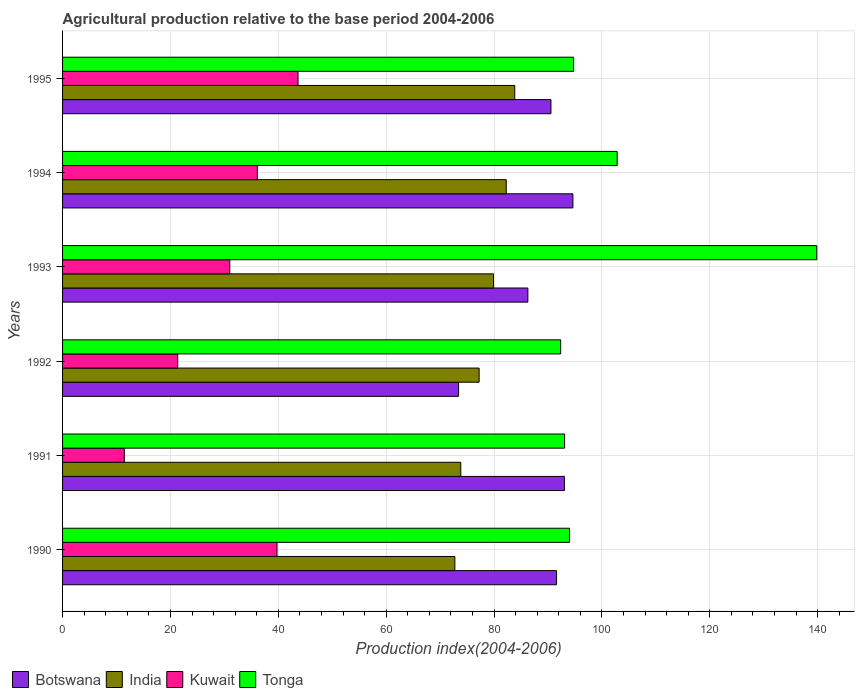How many bars are there on the 1st tick from the top?
Keep it short and to the point. 4. How many bars are there on the 5th tick from the bottom?
Offer a very short reply. 4. In how many cases, is the number of bars for a given year not equal to the number of legend labels?
Give a very brief answer. 0. What is the agricultural production index in Kuwait in 1992?
Give a very brief answer. 21.35. Across all years, what is the maximum agricultural production index in Botswana?
Provide a succinct answer. 94.63. Across all years, what is the minimum agricultural production index in Botswana?
Ensure brevity in your answer.  73.43. In which year was the agricultural production index in India minimum?
Your response must be concise. 1990. What is the total agricultural production index in Tonga in the graph?
Provide a short and direct response. 616.89. What is the difference between the agricultural production index in Kuwait in 1991 and that in 1992?
Give a very brief answer. -9.9. What is the difference between the agricultural production index in India in 1990 and the agricultural production index in Kuwait in 1992?
Provide a short and direct response. 51.39. What is the average agricultural production index in Kuwait per year?
Keep it short and to the point. 30.56. In the year 1994, what is the difference between the agricultural production index in India and agricultural production index in Botswana?
Your answer should be compact. -12.36. In how many years, is the agricultural production index in Tonga greater than 44 ?
Ensure brevity in your answer.  6. What is the ratio of the agricultural production index in Botswana in 1991 to that in 1992?
Keep it short and to the point. 1.27. What is the difference between the highest and the second highest agricultural production index in Botswana?
Give a very brief answer. 1.58. What is the difference between the highest and the lowest agricultural production index in Tonga?
Provide a short and direct response. 47.49. Is the sum of the agricultural production index in Kuwait in 1991 and 1992 greater than the maximum agricultural production index in India across all years?
Give a very brief answer. No. Is it the case that in every year, the sum of the agricultural production index in Kuwait and agricultural production index in Tonga is greater than the sum of agricultural production index in Botswana and agricultural production index in India?
Your answer should be very brief. No. What does the 1st bar from the top in 1995 represents?
Give a very brief answer. Tonga. Are all the bars in the graph horizontal?
Your response must be concise. Yes. How many years are there in the graph?
Your answer should be compact. 6. What is the difference between two consecutive major ticks on the X-axis?
Offer a terse response. 20. Are the values on the major ticks of X-axis written in scientific E-notation?
Your answer should be very brief. No. Does the graph contain any zero values?
Your response must be concise. No. Does the graph contain grids?
Make the answer very short. Yes. How many legend labels are there?
Give a very brief answer. 4. What is the title of the graph?
Offer a terse response. Agricultural production relative to the base period 2004-2006. What is the label or title of the X-axis?
Offer a very short reply. Production index(2004-2006). What is the Production index(2004-2006) in Botswana in 1990?
Offer a terse response. 91.6. What is the Production index(2004-2006) of India in 1990?
Your answer should be compact. 72.74. What is the Production index(2004-2006) of Kuwait in 1990?
Ensure brevity in your answer.  39.76. What is the Production index(2004-2006) in Tonga in 1990?
Your answer should be compact. 94. What is the Production index(2004-2006) of Botswana in 1991?
Keep it short and to the point. 93.05. What is the Production index(2004-2006) in India in 1991?
Provide a succinct answer. 73.84. What is the Production index(2004-2006) of Kuwait in 1991?
Keep it short and to the point. 11.45. What is the Production index(2004-2006) in Tonga in 1991?
Offer a terse response. 93.09. What is the Production index(2004-2006) in Botswana in 1992?
Provide a short and direct response. 73.43. What is the Production index(2004-2006) of India in 1992?
Offer a very short reply. 77.24. What is the Production index(2004-2006) in Kuwait in 1992?
Offer a terse response. 21.35. What is the Production index(2004-2006) of Tonga in 1992?
Your answer should be compact. 92.36. What is the Production index(2004-2006) of Botswana in 1993?
Ensure brevity in your answer.  86.28. What is the Production index(2004-2006) in India in 1993?
Provide a succinct answer. 79.91. What is the Production index(2004-2006) of Kuwait in 1993?
Offer a terse response. 31.01. What is the Production index(2004-2006) of Tonga in 1993?
Your answer should be compact. 139.85. What is the Production index(2004-2006) of Botswana in 1994?
Keep it short and to the point. 94.63. What is the Production index(2004-2006) in India in 1994?
Ensure brevity in your answer.  82.27. What is the Production index(2004-2006) of Kuwait in 1994?
Your answer should be compact. 36.12. What is the Production index(2004-2006) of Tonga in 1994?
Offer a terse response. 102.84. What is the Production index(2004-2006) in Botswana in 1995?
Make the answer very short. 90.56. What is the Production index(2004-2006) of India in 1995?
Make the answer very short. 83.85. What is the Production index(2004-2006) in Kuwait in 1995?
Give a very brief answer. 43.66. What is the Production index(2004-2006) in Tonga in 1995?
Your answer should be compact. 94.75. Across all years, what is the maximum Production index(2004-2006) of Botswana?
Your response must be concise. 94.63. Across all years, what is the maximum Production index(2004-2006) of India?
Provide a short and direct response. 83.85. Across all years, what is the maximum Production index(2004-2006) in Kuwait?
Your answer should be very brief. 43.66. Across all years, what is the maximum Production index(2004-2006) in Tonga?
Offer a terse response. 139.85. Across all years, what is the minimum Production index(2004-2006) of Botswana?
Make the answer very short. 73.43. Across all years, what is the minimum Production index(2004-2006) of India?
Your answer should be very brief. 72.74. Across all years, what is the minimum Production index(2004-2006) of Kuwait?
Make the answer very short. 11.45. Across all years, what is the minimum Production index(2004-2006) in Tonga?
Your answer should be very brief. 92.36. What is the total Production index(2004-2006) of Botswana in the graph?
Offer a terse response. 529.55. What is the total Production index(2004-2006) of India in the graph?
Keep it short and to the point. 469.85. What is the total Production index(2004-2006) in Kuwait in the graph?
Offer a very short reply. 183.35. What is the total Production index(2004-2006) of Tonga in the graph?
Your answer should be compact. 616.89. What is the difference between the Production index(2004-2006) of Botswana in 1990 and that in 1991?
Keep it short and to the point. -1.45. What is the difference between the Production index(2004-2006) of India in 1990 and that in 1991?
Your answer should be compact. -1.1. What is the difference between the Production index(2004-2006) in Kuwait in 1990 and that in 1991?
Keep it short and to the point. 28.31. What is the difference between the Production index(2004-2006) of Tonga in 1990 and that in 1991?
Give a very brief answer. 0.91. What is the difference between the Production index(2004-2006) in Botswana in 1990 and that in 1992?
Provide a succinct answer. 18.17. What is the difference between the Production index(2004-2006) in Kuwait in 1990 and that in 1992?
Your answer should be very brief. 18.41. What is the difference between the Production index(2004-2006) in Tonga in 1990 and that in 1992?
Ensure brevity in your answer.  1.64. What is the difference between the Production index(2004-2006) in Botswana in 1990 and that in 1993?
Offer a very short reply. 5.32. What is the difference between the Production index(2004-2006) in India in 1990 and that in 1993?
Ensure brevity in your answer.  -7.17. What is the difference between the Production index(2004-2006) in Kuwait in 1990 and that in 1993?
Make the answer very short. 8.75. What is the difference between the Production index(2004-2006) of Tonga in 1990 and that in 1993?
Make the answer very short. -45.85. What is the difference between the Production index(2004-2006) of Botswana in 1990 and that in 1994?
Keep it short and to the point. -3.03. What is the difference between the Production index(2004-2006) of India in 1990 and that in 1994?
Your response must be concise. -9.53. What is the difference between the Production index(2004-2006) in Kuwait in 1990 and that in 1994?
Provide a succinct answer. 3.64. What is the difference between the Production index(2004-2006) in Tonga in 1990 and that in 1994?
Your response must be concise. -8.84. What is the difference between the Production index(2004-2006) of Botswana in 1990 and that in 1995?
Your response must be concise. 1.04. What is the difference between the Production index(2004-2006) in India in 1990 and that in 1995?
Provide a short and direct response. -11.11. What is the difference between the Production index(2004-2006) of Tonga in 1990 and that in 1995?
Ensure brevity in your answer.  -0.75. What is the difference between the Production index(2004-2006) in Botswana in 1991 and that in 1992?
Provide a succinct answer. 19.62. What is the difference between the Production index(2004-2006) of Tonga in 1991 and that in 1992?
Offer a terse response. 0.73. What is the difference between the Production index(2004-2006) of Botswana in 1991 and that in 1993?
Provide a short and direct response. 6.77. What is the difference between the Production index(2004-2006) in India in 1991 and that in 1993?
Your answer should be compact. -6.07. What is the difference between the Production index(2004-2006) of Kuwait in 1991 and that in 1993?
Provide a short and direct response. -19.56. What is the difference between the Production index(2004-2006) in Tonga in 1991 and that in 1993?
Keep it short and to the point. -46.76. What is the difference between the Production index(2004-2006) of Botswana in 1991 and that in 1994?
Your response must be concise. -1.58. What is the difference between the Production index(2004-2006) in India in 1991 and that in 1994?
Your response must be concise. -8.43. What is the difference between the Production index(2004-2006) in Kuwait in 1991 and that in 1994?
Offer a very short reply. -24.67. What is the difference between the Production index(2004-2006) of Tonga in 1991 and that in 1994?
Your answer should be very brief. -9.75. What is the difference between the Production index(2004-2006) in Botswana in 1991 and that in 1995?
Your answer should be very brief. 2.49. What is the difference between the Production index(2004-2006) in India in 1991 and that in 1995?
Your response must be concise. -10.01. What is the difference between the Production index(2004-2006) of Kuwait in 1991 and that in 1995?
Offer a terse response. -32.21. What is the difference between the Production index(2004-2006) of Tonga in 1991 and that in 1995?
Keep it short and to the point. -1.66. What is the difference between the Production index(2004-2006) in Botswana in 1992 and that in 1993?
Offer a terse response. -12.85. What is the difference between the Production index(2004-2006) in India in 1992 and that in 1993?
Make the answer very short. -2.67. What is the difference between the Production index(2004-2006) of Kuwait in 1992 and that in 1993?
Keep it short and to the point. -9.66. What is the difference between the Production index(2004-2006) of Tonga in 1992 and that in 1993?
Provide a succinct answer. -47.49. What is the difference between the Production index(2004-2006) in Botswana in 1992 and that in 1994?
Your answer should be compact. -21.2. What is the difference between the Production index(2004-2006) of India in 1992 and that in 1994?
Your response must be concise. -5.03. What is the difference between the Production index(2004-2006) in Kuwait in 1992 and that in 1994?
Offer a very short reply. -14.77. What is the difference between the Production index(2004-2006) in Tonga in 1992 and that in 1994?
Offer a terse response. -10.48. What is the difference between the Production index(2004-2006) of Botswana in 1992 and that in 1995?
Your answer should be very brief. -17.13. What is the difference between the Production index(2004-2006) in India in 1992 and that in 1995?
Give a very brief answer. -6.61. What is the difference between the Production index(2004-2006) in Kuwait in 1992 and that in 1995?
Provide a short and direct response. -22.31. What is the difference between the Production index(2004-2006) in Tonga in 1992 and that in 1995?
Your answer should be very brief. -2.39. What is the difference between the Production index(2004-2006) of Botswana in 1993 and that in 1994?
Your answer should be compact. -8.35. What is the difference between the Production index(2004-2006) in India in 1993 and that in 1994?
Your answer should be compact. -2.36. What is the difference between the Production index(2004-2006) in Kuwait in 1993 and that in 1994?
Provide a short and direct response. -5.11. What is the difference between the Production index(2004-2006) of Tonga in 1993 and that in 1994?
Provide a succinct answer. 37.01. What is the difference between the Production index(2004-2006) in Botswana in 1993 and that in 1995?
Offer a terse response. -4.28. What is the difference between the Production index(2004-2006) in India in 1993 and that in 1995?
Keep it short and to the point. -3.94. What is the difference between the Production index(2004-2006) in Kuwait in 1993 and that in 1995?
Your answer should be compact. -12.65. What is the difference between the Production index(2004-2006) of Tonga in 1993 and that in 1995?
Give a very brief answer. 45.1. What is the difference between the Production index(2004-2006) in Botswana in 1994 and that in 1995?
Keep it short and to the point. 4.07. What is the difference between the Production index(2004-2006) of India in 1994 and that in 1995?
Offer a terse response. -1.58. What is the difference between the Production index(2004-2006) in Kuwait in 1994 and that in 1995?
Offer a terse response. -7.54. What is the difference between the Production index(2004-2006) of Tonga in 1994 and that in 1995?
Make the answer very short. 8.09. What is the difference between the Production index(2004-2006) of Botswana in 1990 and the Production index(2004-2006) of India in 1991?
Your answer should be very brief. 17.76. What is the difference between the Production index(2004-2006) of Botswana in 1990 and the Production index(2004-2006) of Kuwait in 1991?
Make the answer very short. 80.15. What is the difference between the Production index(2004-2006) in Botswana in 1990 and the Production index(2004-2006) in Tonga in 1991?
Your answer should be very brief. -1.49. What is the difference between the Production index(2004-2006) of India in 1990 and the Production index(2004-2006) of Kuwait in 1991?
Provide a succinct answer. 61.29. What is the difference between the Production index(2004-2006) in India in 1990 and the Production index(2004-2006) in Tonga in 1991?
Make the answer very short. -20.35. What is the difference between the Production index(2004-2006) in Kuwait in 1990 and the Production index(2004-2006) in Tonga in 1991?
Make the answer very short. -53.33. What is the difference between the Production index(2004-2006) of Botswana in 1990 and the Production index(2004-2006) of India in 1992?
Your answer should be compact. 14.36. What is the difference between the Production index(2004-2006) in Botswana in 1990 and the Production index(2004-2006) in Kuwait in 1992?
Offer a very short reply. 70.25. What is the difference between the Production index(2004-2006) in Botswana in 1990 and the Production index(2004-2006) in Tonga in 1992?
Your answer should be compact. -0.76. What is the difference between the Production index(2004-2006) in India in 1990 and the Production index(2004-2006) in Kuwait in 1992?
Provide a short and direct response. 51.39. What is the difference between the Production index(2004-2006) of India in 1990 and the Production index(2004-2006) of Tonga in 1992?
Provide a succinct answer. -19.62. What is the difference between the Production index(2004-2006) in Kuwait in 1990 and the Production index(2004-2006) in Tonga in 1992?
Ensure brevity in your answer.  -52.6. What is the difference between the Production index(2004-2006) in Botswana in 1990 and the Production index(2004-2006) in India in 1993?
Offer a terse response. 11.69. What is the difference between the Production index(2004-2006) of Botswana in 1990 and the Production index(2004-2006) of Kuwait in 1993?
Provide a succinct answer. 60.59. What is the difference between the Production index(2004-2006) of Botswana in 1990 and the Production index(2004-2006) of Tonga in 1993?
Provide a succinct answer. -48.25. What is the difference between the Production index(2004-2006) of India in 1990 and the Production index(2004-2006) of Kuwait in 1993?
Offer a very short reply. 41.73. What is the difference between the Production index(2004-2006) in India in 1990 and the Production index(2004-2006) in Tonga in 1993?
Your answer should be compact. -67.11. What is the difference between the Production index(2004-2006) of Kuwait in 1990 and the Production index(2004-2006) of Tonga in 1993?
Offer a terse response. -100.09. What is the difference between the Production index(2004-2006) of Botswana in 1990 and the Production index(2004-2006) of India in 1994?
Give a very brief answer. 9.33. What is the difference between the Production index(2004-2006) of Botswana in 1990 and the Production index(2004-2006) of Kuwait in 1994?
Ensure brevity in your answer.  55.48. What is the difference between the Production index(2004-2006) in Botswana in 1990 and the Production index(2004-2006) in Tonga in 1994?
Ensure brevity in your answer.  -11.24. What is the difference between the Production index(2004-2006) in India in 1990 and the Production index(2004-2006) in Kuwait in 1994?
Ensure brevity in your answer.  36.62. What is the difference between the Production index(2004-2006) in India in 1990 and the Production index(2004-2006) in Tonga in 1994?
Offer a terse response. -30.1. What is the difference between the Production index(2004-2006) of Kuwait in 1990 and the Production index(2004-2006) of Tonga in 1994?
Make the answer very short. -63.08. What is the difference between the Production index(2004-2006) in Botswana in 1990 and the Production index(2004-2006) in India in 1995?
Make the answer very short. 7.75. What is the difference between the Production index(2004-2006) of Botswana in 1990 and the Production index(2004-2006) of Kuwait in 1995?
Keep it short and to the point. 47.94. What is the difference between the Production index(2004-2006) of Botswana in 1990 and the Production index(2004-2006) of Tonga in 1995?
Offer a terse response. -3.15. What is the difference between the Production index(2004-2006) of India in 1990 and the Production index(2004-2006) of Kuwait in 1995?
Keep it short and to the point. 29.08. What is the difference between the Production index(2004-2006) in India in 1990 and the Production index(2004-2006) in Tonga in 1995?
Your answer should be very brief. -22.01. What is the difference between the Production index(2004-2006) of Kuwait in 1990 and the Production index(2004-2006) of Tonga in 1995?
Keep it short and to the point. -54.99. What is the difference between the Production index(2004-2006) of Botswana in 1991 and the Production index(2004-2006) of India in 1992?
Give a very brief answer. 15.81. What is the difference between the Production index(2004-2006) of Botswana in 1991 and the Production index(2004-2006) of Kuwait in 1992?
Provide a short and direct response. 71.7. What is the difference between the Production index(2004-2006) in Botswana in 1991 and the Production index(2004-2006) in Tonga in 1992?
Provide a succinct answer. 0.69. What is the difference between the Production index(2004-2006) of India in 1991 and the Production index(2004-2006) of Kuwait in 1992?
Ensure brevity in your answer.  52.49. What is the difference between the Production index(2004-2006) in India in 1991 and the Production index(2004-2006) in Tonga in 1992?
Provide a short and direct response. -18.52. What is the difference between the Production index(2004-2006) of Kuwait in 1991 and the Production index(2004-2006) of Tonga in 1992?
Ensure brevity in your answer.  -80.91. What is the difference between the Production index(2004-2006) in Botswana in 1991 and the Production index(2004-2006) in India in 1993?
Provide a short and direct response. 13.14. What is the difference between the Production index(2004-2006) in Botswana in 1991 and the Production index(2004-2006) in Kuwait in 1993?
Your answer should be compact. 62.04. What is the difference between the Production index(2004-2006) of Botswana in 1991 and the Production index(2004-2006) of Tonga in 1993?
Your response must be concise. -46.8. What is the difference between the Production index(2004-2006) in India in 1991 and the Production index(2004-2006) in Kuwait in 1993?
Your answer should be very brief. 42.83. What is the difference between the Production index(2004-2006) in India in 1991 and the Production index(2004-2006) in Tonga in 1993?
Offer a very short reply. -66.01. What is the difference between the Production index(2004-2006) in Kuwait in 1991 and the Production index(2004-2006) in Tonga in 1993?
Make the answer very short. -128.4. What is the difference between the Production index(2004-2006) of Botswana in 1991 and the Production index(2004-2006) of India in 1994?
Your answer should be very brief. 10.78. What is the difference between the Production index(2004-2006) of Botswana in 1991 and the Production index(2004-2006) of Kuwait in 1994?
Your answer should be very brief. 56.93. What is the difference between the Production index(2004-2006) in Botswana in 1991 and the Production index(2004-2006) in Tonga in 1994?
Your response must be concise. -9.79. What is the difference between the Production index(2004-2006) of India in 1991 and the Production index(2004-2006) of Kuwait in 1994?
Your answer should be compact. 37.72. What is the difference between the Production index(2004-2006) of Kuwait in 1991 and the Production index(2004-2006) of Tonga in 1994?
Offer a terse response. -91.39. What is the difference between the Production index(2004-2006) in Botswana in 1991 and the Production index(2004-2006) in India in 1995?
Offer a very short reply. 9.2. What is the difference between the Production index(2004-2006) in Botswana in 1991 and the Production index(2004-2006) in Kuwait in 1995?
Your answer should be very brief. 49.39. What is the difference between the Production index(2004-2006) of Botswana in 1991 and the Production index(2004-2006) of Tonga in 1995?
Make the answer very short. -1.7. What is the difference between the Production index(2004-2006) of India in 1991 and the Production index(2004-2006) of Kuwait in 1995?
Keep it short and to the point. 30.18. What is the difference between the Production index(2004-2006) of India in 1991 and the Production index(2004-2006) of Tonga in 1995?
Offer a terse response. -20.91. What is the difference between the Production index(2004-2006) in Kuwait in 1991 and the Production index(2004-2006) in Tonga in 1995?
Your answer should be very brief. -83.3. What is the difference between the Production index(2004-2006) in Botswana in 1992 and the Production index(2004-2006) in India in 1993?
Offer a very short reply. -6.48. What is the difference between the Production index(2004-2006) in Botswana in 1992 and the Production index(2004-2006) in Kuwait in 1993?
Make the answer very short. 42.42. What is the difference between the Production index(2004-2006) of Botswana in 1992 and the Production index(2004-2006) of Tonga in 1993?
Provide a short and direct response. -66.42. What is the difference between the Production index(2004-2006) in India in 1992 and the Production index(2004-2006) in Kuwait in 1993?
Provide a short and direct response. 46.23. What is the difference between the Production index(2004-2006) in India in 1992 and the Production index(2004-2006) in Tonga in 1993?
Provide a short and direct response. -62.61. What is the difference between the Production index(2004-2006) of Kuwait in 1992 and the Production index(2004-2006) of Tonga in 1993?
Your answer should be very brief. -118.5. What is the difference between the Production index(2004-2006) in Botswana in 1992 and the Production index(2004-2006) in India in 1994?
Your response must be concise. -8.84. What is the difference between the Production index(2004-2006) in Botswana in 1992 and the Production index(2004-2006) in Kuwait in 1994?
Keep it short and to the point. 37.31. What is the difference between the Production index(2004-2006) in Botswana in 1992 and the Production index(2004-2006) in Tonga in 1994?
Provide a succinct answer. -29.41. What is the difference between the Production index(2004-2006) in India in 1992 and the Production index(2004-2006) in Kuwait in 1994?
Make the answer very short. 41.12. What is the difference between the Production index(2004-2006) of India in 1992 and the Production index(2004-2006) of Tonga in 1994?
Your response must be concise. -25.6. What is the difference between the Production index(2004-2006) in Kuwait in 1992 and the Production index(2004-2006) in Tonga in 1994?
Your answer should be very brief. -81.49. What is the difference between the Production index(2004-2006) in Botswana in 1992 and the Production index(2004-2006) in India in 1995?
Provide a short and direct response. -10.42. What is the difference between the Production index(2004-2006) in Botswana in 1992 and the Production index(2004-2006) in Kuwait in 1995?
Provide a short and direct response. 29.77. What is the difference between the Production index(2004-2006) in Botswana in 1992 and the Production index(2004-2006) in Tonga in 1995?
Provide a short and direct response. -21.32. What is the difference between the Production index(2004-2006) in India in 1992 and the Production index(2004-2006) in Kuwait in 1995?
Keep it short and to the point. 33.58. What is the difference between the Production index(2004-2006) of India in 1992 and the Production index(2004-2006) of Tonga in 1995?
Your answer should be very brief. -17.51. What is the difference between the Production index(2004-2006) in Kuwait in 1992 and the Production index(2004-2006) in Tonga in 1995?
Offer a very short reply. -73.4. What is the difference between the Production index(2004-2006) of Botswana in 1993 and the Production index(2004-2006) of India in 1994?
Your response must be concise. 4.01. What is the difference between the Production index(2004-2006) in Botswana in 1993 and the Production index(2004-2006) in Kuwait in 1994?
Your answer should be very brief. 50.16. What is the difference between the Production index(2004-2006) in Botswana in 1993 and the Production index(2004-2006) in Tonga in 1994?
Make the answer very short. -16.56. What is the difference between the Production index(2004-2006) of India in 1993 and the Production index(2004-2006) of Kuwait in 1994?
Keep it short and to the point. 43.79. What is the difference between the Production index(2004-2006) of India in 1993 and the Production index(2004-2006) of Tonga in 1994?
Your answer should be compact. -22.93. What is the difference between the Production index(2004-2006) in Kuwait in 1993 and the Production index(2004-2006) in Tonga in 1994?
Provide a short and direct response. -71.83. What is the difference between the Production index(2004-2006) in Botswana in 1993 and the Production index(2004-2006) in India in 1995?
Your answer should be compact. 2.43. What is the difference between the Production index(2004-2006) in Botswana in 1993 and the Production index(2004-2006) in Kuwait in 1995?
Offer a very short reply. 42.62. What is the difference between the Production index(2004-2006) in Botswana in 1993 and the Production index(2004-2006) in Tonga in 1995?
Offer a terse response. -8.47. What is the difference between the Production index(2004-2006) of India in 1993 and the Production index(2004-2006) of Kuwait in 1995?
Give a very brief answer. 36.25. What is the difference between the Production index(2004-2006) of India in 1993 and the Production index(2004-2006) of Tonga in 1995?
Your answer should be very brief. -14.84. What is the difference between the Production index(2004-2006) in Kuwait in 1993 and the Production index(2004-2006) in Tonga in 1995?
Make the answer very short. -63.74. What is the difference between the Production index(2004-2006) in Botswana in 1994 and the Production index(2004-2006) in India in 1995?
Keep it short and to the point. 10.78. What is the difference between the Production index(2004-2006) of Botswana in 1994 and the Production index(2004-2006) of Kuwait in 1995?
Give a very brief answer. 50.97. What is the difference between the Production index(2004-2006) in Botswana in 1994 and the Production index(2004-2006) in Tonga in 1995?
Offer a very short reply. -0.12. What is the difference between the Production index(2004-2006) in India in 1994 and the Production index(2004-2006) in Kuwait in 1995?
Provide a succinct answer. 38.61. What is the difference between the Production index(2004-2006) of India in 1994 and the Production index(2004-2006) of Tonga in 1995?
Your answer should be very brief. -12.48. What is the difference between the Production index(2004-2006) in Kuwait in 1994 and the Production index(2004-2006) in Tonga in 1995?
Offer a very short reply. -58.63. What is the average Production index(2004-2006) in Botswana per year?
Your answer should be compact. 88.26. What is the average Production index(2004-2006) of India per year?
Give a very brief answer. 78.31. What is the average Production index(2004-2006) in Kuwait per year?
Keep it short and to the point. 30.56. What is the average Production index(2004-2006) of Tonga per year?
Your answer should be compact. 102.81. In the year 1990, what is the difference between the Production index(2004-2006) of Botswana and Production index(2004-2006) of India?
Give a very brief answer. 18.86. In the year 1990, what is the difference between the Production index(2004-2006) of Botswana and Production index(2004-2006) of Kuwait?
Provide a succinct answer. 51.84. In the year 1990, what is the difference between the Production index(2004-2006) in India and Production index(2004-2006) in Kuwait?
Provide a short and direct response. 32.98. In the year 1990, what is the difference between the Production index(2004-2006) of India and Production index(2004-2006) of Tonga?
Ensure brevity in your answer.  -21.26. In the year 1990, what is the difference between the Production index(2004-2006) in Kuwait and Production index(2004-2006) in Tonga?
Offer a very short reply. -54.24. In the year 1991, what is the difference between the Production index(2004-2006) in Botswana and Production index(2004-2006) in India?
Provide a succinct answer. 19.21. In the year 1991, what is the difference between the Production index(2004-2006) in Botswana and Production index(2004-2006) in Kuwait?
Give a very brief answer. 81.6. In the year 1991, what is the difference between the Production index(2004-2006) of Botswana and Production index(2004-2006) of Tonga?
Provide a short and direct response. -0.04. In the year 1991, what is the difference between the Production index(2004-2006) in India and Production index(2004-2006) in Kuwait?
Your response must be concise. 62.39. In the year 1991, what is the difference between the Production index(2004-2006) in India and Production index(2004-2006) in Tonga?
Ensure brevity in your answer.  -19.25. In the year 1991, what is the difference between the Production index(2004-2006) in Kuwait and Production index(2004-2006) in Tonga?
Ensure brevity in your answer.  -81.64. In the year 1992, what is the difference between the Production index(2004-2006) in Botswana and Production index(2004-2006) in India?
Make the answer very short. -3.81. In the year 1992, what is the difference between the Production index(2004-2006) in Botswana and Production index(2004-2006) in Kuwait?
Your answer should be compact. 52.08. In the year 1992, what is the difference between the Production index(2004-2006) of Botswana and Production index(2004-2006) of Tonga?
Offer a terse response. -18.93. In the year 1992, what is the difference between the Production index(2004-2006) of India and Production index(2004-2006) of Kuwait?
Provide a succinct answer. 55.89. In the year 1992, what is the difference between the Production index(2004-2006) of India and Production index(2004-2006) of Tonga?
Your answer should be very brief. -15.12. In the year 1992, what is the difference between the Production index(2004-2006) in Kuwait and Production index(2004-2006) in Tonga?
Keep it short and to the point. -71.01. In the year 1993, what is the difference between the Production index(2004-2006) of Botswana and Production index(2004-2006) of India?
Give a very brief answer. 6.37. In the year 1993, what is the difference between the Production index(2004-2006) of Botswana and Production index(2004-2006) of Kuwait?
Give a very brief answer. 55.27. In the year 1993, what is the difference between the Production index(2004-2006) of Botswana and Production index(2004-2006) of Tonga?
Offer a terse response. -53.57. In the year 1993, what is the difference between the Production index(2004-2006) in India and Production index(2004-2006) in Kuwait?
Offer a very short reply. 48.9. In the year 1993, what is the difference between the Production index(2004-2006) of India and Production index(2004-2006) of Tonga?
Offer a terse response. -59.94. In the year 1993, what is the difference between the Production index(2004-2006) in Kuwait and Production index(2004-2006) in Tonga?
Ensure brevity in your answer.  -108.84. In the year 1994, what is the difference between the Production index(2004-2006) in Botswana and Production index(2004-2006) in India?
Give a very brief answer. 12.36. In the year 1994, what is the difference between the Production index(2004-2006) of Botswana and Production index(2004-2006) of Kuwait?
Provide a succinct answer. 58.51. In the year 1994, what is the difference between the Production index(2004-2006) in Botswana and Production index(2004-2006) in Tonga?
Your answer should be compact. -8.21. In the year 1994, what is the difference between the Production index(2004-2006) in India and Production index(2004-2006) in Kuwait?
Your answer should be very brief. 46.15. In the year 1994, what is the difference between the Production index(2004-2006) in India and Production index(2004-2006) in Tonga?
Provide a short and direct response. -20.57. In the year 1994, what is the difference between the Production index(2004-2006) in Kuwait and Production index(2004-2006) in Tonga?
Offer a very short reply. -66.72. In the year 1995, what is the difference between the Production index(2004-2006) in Botswana and Production index(2004-2006) in India?
Your answer should be very brief. 6.71. In the year 1995, what is the difference between the Production index(2004-2006) in Botswana and Production index(2004-2006) in Kuwait?
Provide a short and direct response. 46.9. In the year 1995, what is the difference between the Production index(2004-2006) of Botswana and Production index(2004-2006) of Tonga?
Your answer should be compact. -4.19. In the year 1995, what is the difference between the Production index(2004-2006) of India and Production index(2004-2006) of Kuwait?
Offer a terse response. 40.19. In the year 1995, what is the difference between the Production index(2004-2006) of India and Production index(2004-2006) of Tonga?
Offer a very short reply. -10.9. In the year 1995, what is the difference between the Production index(2004-2006) of Kuwait and Production index(2004-2006) of Tonga?
Give a very brief answer. -51.09. What is the ratio of the Production index(2004-2006) in Botswana in 1990 to that in 1991?
Provide a short and direct response. 0.98. What is the ratio of the Production index(2004-2006) in India in 1990 to that in 1991?
Keep it short and to the point. 0.99. What is the ratio of the Production index(2004-2006) of Kuwait in 1990 to that in 1991?
Your response must be concise. 3.47. What is the ratio of the Production index(2004-2006) in Tonga in 1990 to that in 1991?
Your response must be concise. 1.01. What is the ratio of the Production index(2004-2006) of Botswana in 1990 to that in 1992?
Provide a succinct answer. 1.25. What is the ratio of the Production index(2004-2006) of India in 1990 to that in 1992?
Offer a very short reply. 0.94. What is the ratio of the Production index(2004-2006) of Kuwait in 1990 to that in 1992?
Keep it short and to the point. 1.86. What is the ratio of the Production index(2004-2006) in Tonga in 1990 to that in 1992?
Provide a short and direct response. 1.02. What is the ratio of the Production index(2004-2006) in Botswana in 1990 to that in 1993?
Offer a very short reply. 1.06. What is the ratio of the Production index(2004-2006) of India in 1990 to that in 1993?
Provide a short and direct response. 0.91. What is the ratio of the Production index(2004-2006) of Kuwait in 1990 to that in 1993?
Your answer should be very brief. 1.28. What is the ratio of the Production index(2004-2006) of Tonga in 1990 to that in 1993?
Give a very brief answer. 0.67. What is the ratio of the Production index(2004-2006) in India in 1990 to that in 1994?
Your response must be concise. 0.88. What is the ratio of the Production index(2004-2006) of Kuwait in 1990 to that in 1994?
Provide a succinct answer. 1.1. What is the ratio of the Production index(2004-2006) in Tonga in 1990 to that in 1994?
Your answer should be compact. 0.91. What is the ratio of the Production index(2004-2006) of Botswana in 1990 to that in 1995?
Your response must be concise. 1.01. What is the ratio of the Production index(2004-2006) in India in 1990 to that in 1995?
Your response must be concise. 0.87. What is the ratio of the Production index(2004-2006) of Kuwait in 1990 to that in 1995?
Provide a short and direct response. 0.91. What is the ratio of the Production index(2004-2006) in Botswana in 1991 to that in 1992?
Keep it short and to the point. 1.27. What is the ratio of the Production index(2004-2006) of India in 1991 to that in 1992?
Offer a very short reply. 0.96. What is the ratio of the Production index(2004-2006) of Kuwait in 1991 to that in 1992?
Offer a terse response. 0.54. What is the ratio of the Production index(2004-2006) in Tonga in 1991 to that in 1992?
Your answer should be compact. 1.01. What is the ratio of the Production index(2004-2006) of Botswana in 1991 to that in 1993?
Give a very brief answer. 1.08. What is the ratio of the Production index(2004-2006) in India in 1991 to that in 1993?
Your answer should be compact. 0.92. What is the ratio of the Production index(2004-2006) in Kuwait in 1991 to that in 1993?
Your answer should be very brief. 0.37. What is the ratio of the Production index(2004-2006) of Tonga in 1991 to that in 1993?
Ensure brevity in your answer.  0.67. What is the ratio of the Production index(2004-2006) in Botswana in 1991 to that in 1994?
Offer a very short reply. 0.98. What is the ratio of the Production index(2004-2006) of India in 1991 to that in 1994?
Offer a terse response. 0.9. What is the ratio of the Production index(2004-2006) of Kuwait in 1991 to that in 1994?
Give a very brief answer. 0.32. What is the ratio of the Production index(2004-2006) of Tonga in 1991 to that in 1994?
Your answer should be very brief. 0.91. What is the ratio of the Production index(2004-2006) of Botswana in 1991 to that in 1995?
Give a very brief answer. 1.03. What is the ratio of the Production index(2004-2006) in India in 1991 to that in 1995?
Give a very brief answer. 0.88. What is the ratio of the Production index(2004-2006) in Kuwait in 1991 to that in 1995?
Your response must be concise. 0.26. What is the ratio of the Production index(2004-2006) in Tonga in 1991 to that in 1995?
Provide a succinct answer. 0.98. What is the ratio of the Production index(2004-2006) in Botswana in 1992 to that in 1993?
Offer a very short reply. 0.85. What is the ratio of the Production index(2004-2006) of India in 1992 to that in 1993?
Offer a terse response. 0.97. What is the ratio of the Production index(2004-2006) of Kuwait in 1992 to that in 1993?
Make the answer very short. 0.69. What is the ratio of the Production index(2004-2006) of Tonga in 1992 to that in 1993?
Offer a very short reply. 0.66. What is the ratio of the Production index(2004-2006) in Botswana in 1992 to that in 1994?
Your response must be concise. 0.78. What is the ratio of the Production index(2004-2006) in India in 1992 to that in 1994?
Your answer should be very brief. 0.94. What is the ratio of the Production index(2004-2006) in Kuwait in 1992 to that in 1994?
Provide a short and direct response. 0.59. What is the ratio of the Production index(2004-2006) of Tonga in 1992 to that in 1994?
Give a very brief answer. 0.9. What is the ratio of the Production index(2004-2006) of Botswana in 1992 to that in 1995?
Your response must be concise. 0.81. What is the ratio of the Production index(2004-2006) of India in 1992 to that in 1995?
Your answer should be compact. 0.92. What is the ratio of the Production index(2004-2006) in Kuwait in 1992 to that in 1995?
Your response must be concise. 0.49. What is the ratio of the Production index(2004-2006) in Tonga in 1992 to that in 1995?
Offer a terse response. 0.97. What is the ratio of the Production index(2004-2006) of Botswana in 1993 to that in 1994?
Your answer should be compact. 0.91. What is the ratio of the Production index(2004-2006) in India in 1993 to that in 1994?
Keep it short and to the point. 0.97. What is the ratio of the Production index(2004-2006) of Kuwait in 1993 to that in 1994?
Ensure brevity in your answer.  0.86. What is the ratio of the Production index(2004-2006) of Tonga in 1993 to that in 1994?
Provide a succinct answer. 1.36. What is the ratio of the Production index(2004-2006) of Botswana in 1993 to that in 1995?
Make the answer very short. 0.95. What is the ratio of the Production index(2004-2006) in India in 1993 to that in 1995?
Offer a very short reply. 0.95. What is the ratio of the Production index(2004-2006) of Kuwait in 1993 to that in 1995?
Your answer should be compact. 0.71. What is the ratio of the Production index(2004-2006) of Tonga in 1993 to that in 1995?
Your answer should be very brief. 1.48. What is the ratio of the Production index(2004-2006) in Botswana in 1994 to that in 1995?
Offer a terse response. 1.04. What is the ratio of the Production index(2004-2006) in India in 1994 to that in 1995?
Give a very brief answer. 0.98. What is the ratio of the Production index(2004-2006) of Kuwait in 1994 to that in 1995?
Ensure brevity in your answer.  0.83. What is the ratio of the Production index(2004-2006) in Tonga in 1994 to that in 1995?
Your answer should be compact. 1.09. What is the difference between the highest and the second highest Production index(2004-2006) of Botswana?
Give a very brief answer. 1.58. What is the difference between the highest and the second highest Production index(2004-2006) of India?
Offer a terse response. 1.58. What is the difference between the highest and the second highest Production index(2004-2006) in Kuwait?
Your answer should be compact. 3.9. What is the difference between the highest and the second highest Production index(2004-2006) in Tonga?
Your answer should be compact. 37.01. What is the difference between the highest and the lowest Production index(2004-2006) in Botswana?
Your answer should be compact. 21.2. What is the difference between the highest and the lowest Production index(2004-2006) of India?
Provide a succinct answer. 11.11. What is the difference between the highest and the lowest Production index(2004-2006) in Kuwait?
Your answer should be very brief. 32.21. What is the difference between the highest and the lowest Production index(2004-2006) of Tonga?
Offer a terse response. 47.49. 